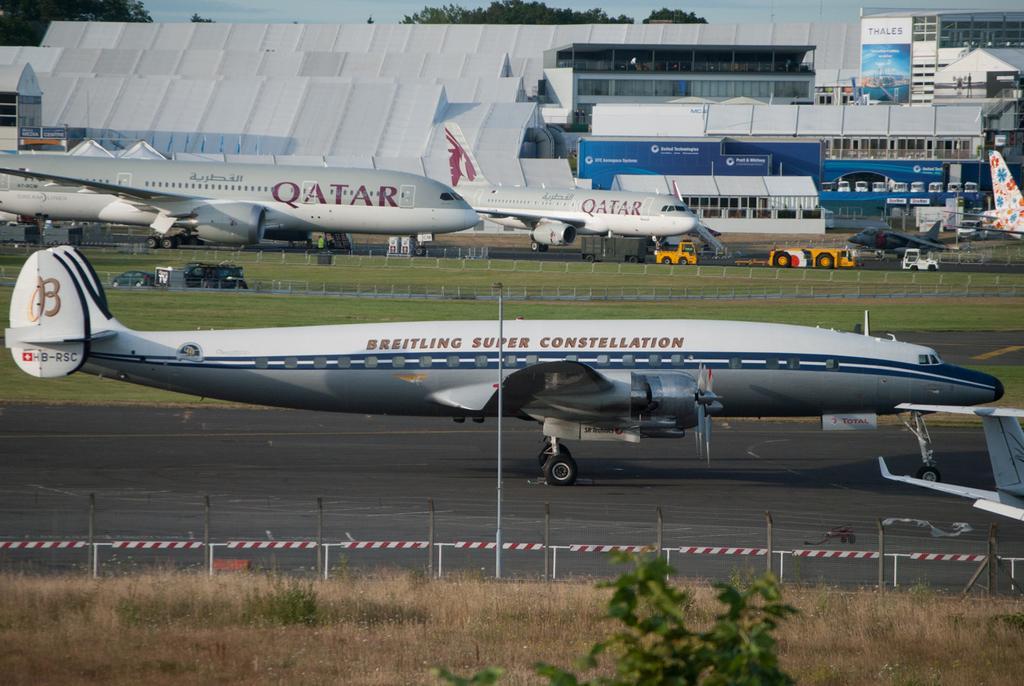Could you give a brief overview of what you see in this image? This image consists of airplanes in white color. At the bottom, there is a road. And there is dry grass on the ground. In the background, there is a building. It looks like an airport. At the top, we can see the trees along with the sky. 